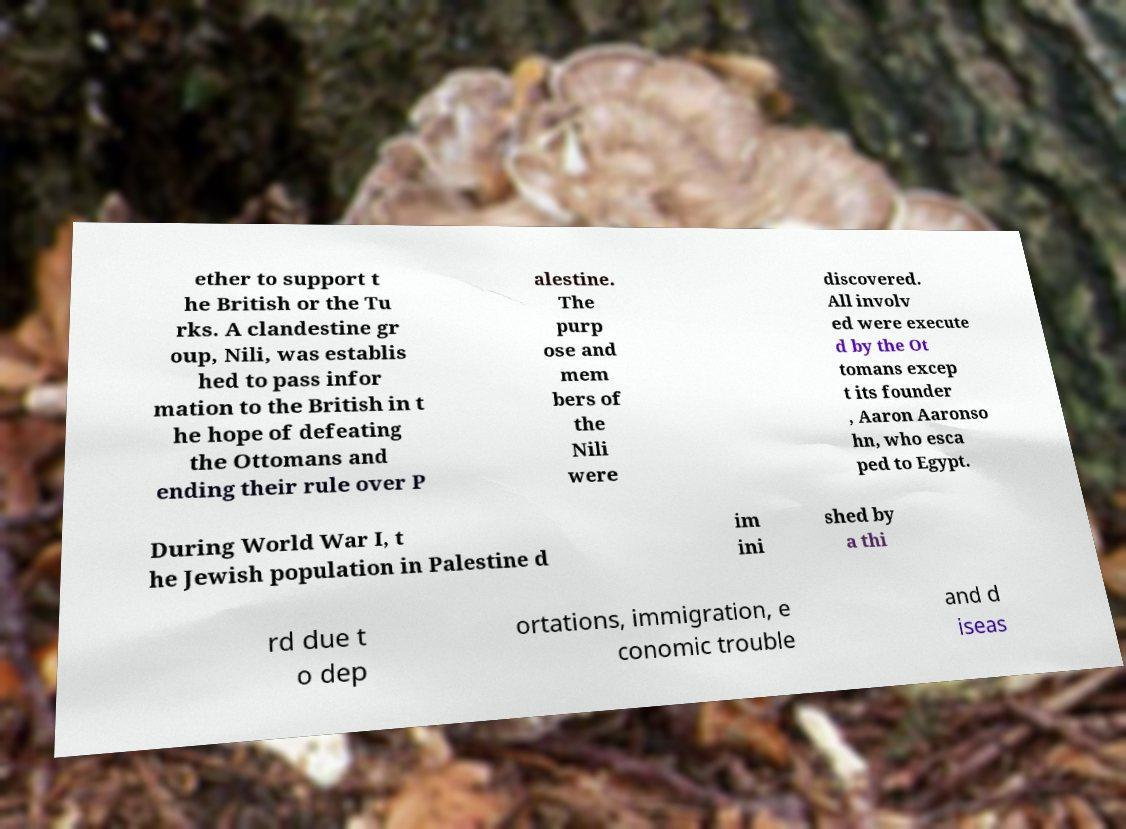Can you accurately transcribe the text from the provided image for me? ether to support t he British or the Tu rks. A clandestine gr oup, Nili, was establis hed to pass infor mation to the British in t he hope of defeating the Ottomans and ending their rule over P alestine. The purp ose and mem bers of the Nili were discovered. All involv ed were execute d by the Ot tomans excep t its founder , Aaron Aaronso hn, who esca ped to Egypt. During World War I, t he Jewish population in Palestine d im ini shed by a thi rd due t o dep ortations, immigration, e conomic trouble and d iseas 